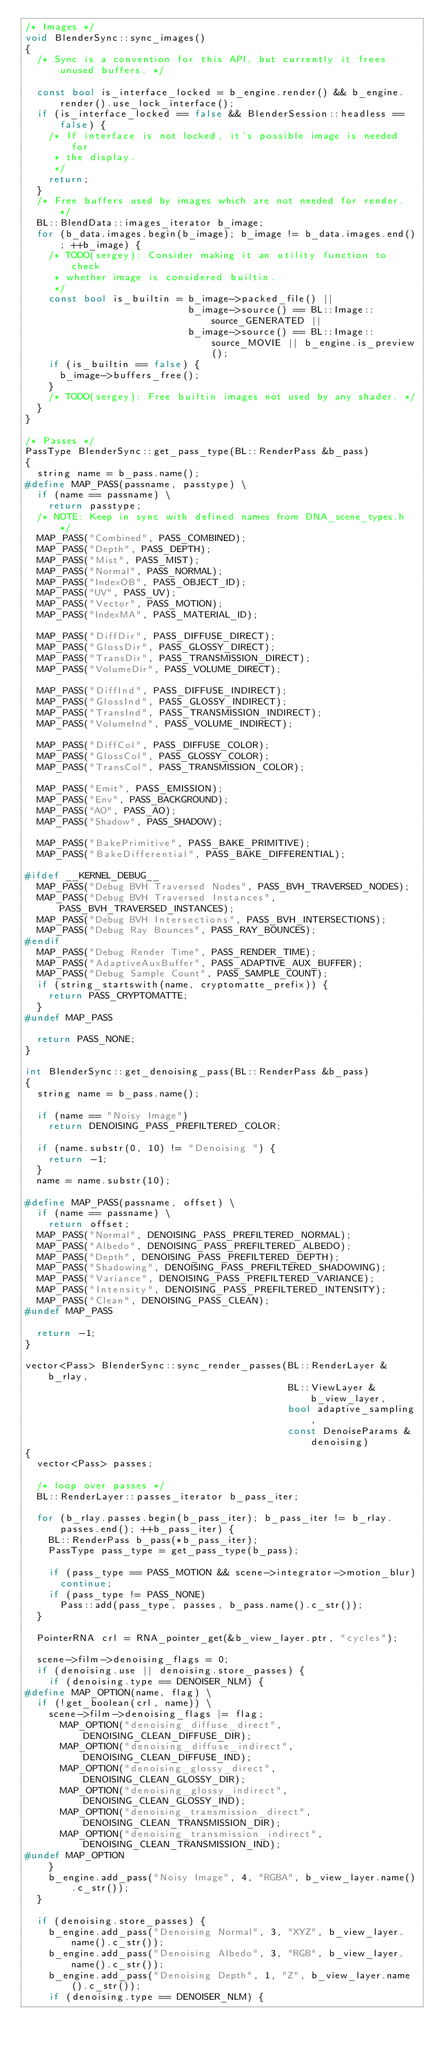Convert code to text. <code><loc_0><loc_0><loc_500><loc_500><_C++_>/* Images */
void BlenderSync::sync_images()
{
  /* Sync is a convention for this API, but currently it frees unused buffers. */

  const bool is_interface_locked = b_engine.render() && b_engine.render().use_lock_interface();
  if (is_interface_locked == false && BlenderSession::headless == false) {
    /* If interface is not locked, it's possible image is needed for
     * the display.
     */
    return;
  }
  /* Free buffers used by images which are not needed for render. */
  BL::BlendData::images_iterator b_image;
  for (b_data.images.begin(b_image); b_image != b_data.images.end(); ++b_image) {
    /* TODO(sergey): Consider making it an utility function to check
     * whether image is considered builtin.
     */
    const bool is_builtin = b_image->packed_file() ||
                            b_image->source() == BL::Image::source_GENERATED ||
                            b_image->source() == BL::Image::source_MOVIE || b_engine.is_preview();
    if (is_builtin == false) {
      b_image->buffers_free();
    }
    /* TODO(sergey): Free builtin images not used by any shader. */
  }
}

/* Passes */
PassType BlenderSync::get_pass_type(BL::RenderPass &b_pass)
{
  string name = b_pass.name();
#define MAP_PASS(passname, passtype) \
  if (name == passname) \
    return passtype;
  /* NOTE: Keep in sync with defined names from DNA_scene_types.h */
  MAP_PASS("Combined", PASS_COMBINED);
  MAP_PASS("Depth", PASS_DEPTH);
  MAP_PASS("Mist", PASS_MIST);
  MAP_PASS("Normal", PASS_NORMAL);
  MAP_PASS("IndexOB", PASS_OBJECT_ID);
  MAP_PASS("UV", PASS_UV);
  MAP_PASS("Vector", PASS_MOTION);
  MAP_PASS("IndexMA", PASS_MATERIAL_ID);

  MAP_PASS("DiffDir", PASS_DIFFUSE_DIRECT);
  MAP_PASS("GlossDir", PASS_GLOSSY_DIRECT);
  MAP_PASS("TransDir", PASS_TRANSMISSION_DIRECT);
  MAP_PASS("VolumeDir", PASS_VOLUME_DIRECT);

  MAP_PASS("DiffInd", PASS_DIFFUSE_INDIRECT);
  MAP_PASS("GlossInd", PASS_GLOSSY_INDIRECT);
  MAP_PASS("TransInd", PASS_TRANSMISSION_INDIRECT);
  MAP_PASS("VolumeInd", PASS_VOLUME_INDIRECT);

  MAP_PASS("DiffCol", PASS_DIFFUSE_COLOR);
  MAP_PASS("GlossCol", PASS_GLOSSY_COLOR);
  MAP_PASS("TransCol", PASS_TRANSMISSION_COLOR);

  MAP_PASS("Emit", PASS_EMISSION);
  MAP_PASS("Env", PASS_BACKGROUND);
  MAP_PASS("AO", PASS_AO);
  MAP_PASS("Shadow", PASS_SHADOW);

  MAP_PASS("BakePrimitive", PASS_BAKE_PRIMITIVE);
  MAP_PASS("BakeDifferential", PASS_BAKE_DIFFERENTIAL);

#ifdef __KERNEL_DEBUG__
  MAP_PASS("Debug BVH Traversed Nodes", PASS_BVH_TRAVERSED_NODES);
  MAP_PASS("Debug BVH Traversed Instances", PASS_BVH_TRAVERSED_INSTANCES);
  MAP_PASS("Debug BVH Intersections", PASS_BVH_INTERSECTIONS);
  MAP_PASS("Debug Ray Bounces", PASS_RAY_BOUNCES);
#endif
  MAP_PASS("Debug Render Time", PASS_RENDER_TIME);
  MAP_PASS("AdaptiveAuxBuffer", PASS_ADAPTIVE_AUX_BUFFER);
  MAP_PASS("Debug Sample Count", PASS_SAMPLE_COUNT);
  if (string_startswith(name, cryptomatte_prefix)) {
    return PASS_CRYPTOMATTE;
  }
#undef MAP_PASS

  return PASS_NONE;
}

int BlenderSync::get_denoising_pass(BL::RenderPass &b_pass)
{
  string name = b_pass.name();

  if (name == "Noisy Image")
    return DENOISING_PASS_PREFILTERED_COLOR;

  if (name.substr(0, 10) != "Denoising ") {
    return -1;
  }
  name = name.substr(10);

#define MAP_PASS(passname, offset) \
  if (name == passname) \
    return offset;
  MAP_PASS("Normal", DENOISING_PASS_PREFILTERED_NORMAL);
  MAP_PASS("Albedo", DENOISING_PASS_PREFILTERED_ALBEDO);
  MAP_PASS("Depth", DENOISING_PASS_PREFILTERED_DEPTH);
  MAP_PASS("Shadowing", DENOISING_PASS_PREFILTERED_SHADOWING);
  MAP_PASS("Variance", DENOISING_PASS_PREFILTERED_VARIANCE);
  MAP_PASS("Intensity", DENOISING_PASS_PREFILTERED_INTENSITY);
  MAP_PASS("Clean", DENOISING_PASS_CLEAN);
#undef MAP_PASS

  return -1;
}

vector<Pass> BlenderSync::sync_render_passes(BL::RenderLayer &b_rlay,
                                             BL::ViewLayer &b_view_layer,
                                             bool adaptive_sampling,
                                             const DenoiseParams &denoising)
{
  vector<Pass> passes;

  /* loop over passes */
  BL::RenderLayer::passes_iterator b_pass_iter;

  for (b_rlay.passes.begin(b_pass_iter); b_pass_iter != b_rlay.passes.end(); ++b_pass_iter) {
    BL::RenderPass b_pass(*b_pass_iter);
    PassType pass_type = get_pass_type(b_pass);

    if (pass_type == PASS_MOTION && scene->integrator->motion_blur)
      continue;
    if (pass_type != PASS_NONE)
      Pass::add(pass_type, passes, b_pass.name().c_str());
  }

  PointerRNA crl = RNA_pointer_get(&b_view_layer.ptr, "cycles");

  scene->film->denoising_flags = 0;
  if (denoising.use || denoising.store_passes) {
    if (denoising.type == DENOISER_NLM) {
#define MAP_OPTION(name, flag) \
  if (!get_boolean(crl, name)) \
    scene->film->denoising_flags |= flag;
      MAP_OPTION("denoising_diffuse_direct", DENOISING_CLEAN_DIFFUSE_DIR);
      MAP_OPTION("denoising_diffuse_indirect", DENOISING_CLEAN_DIFFUSE_IND);
      MAP_OPTION("denoising_glossy_direct", DENOISING_CLEAN_GLOSSY_DIR);
      MAP_OPTION("denoising_glossy_indirect", DENOISING_CLEAN_GLOSSY_IND);
      MAP_OPTION("denoising_transmission_direct", DENOISING_CLEAN_TRANSMISSION_DIR);
      MAP_OPTION("denoising_transmission_indirect", DENOISING_CLEAN_TRANSMISSION_IND);
#undef MAP_OPTION
    }
    b_engine.add_pass("Noisy Image", 4, "RGBA", b_view_layer.name().c_str());
  }

  if (denoising.store_passes) {
    b_engine.add_pass("Denoising Normal", 3, "XYZ", b_view_layer.name().c_str());
    b_engine.add_pass("Denoising Albedo", 3, "RGB", b_view_layer.name().c_str());
    b_engine.add_pass("Denoising Depth", 1, "Z", b_view_layer.name().c_str());
    if (denoising.type == DENOISER_NLM) {</code> 